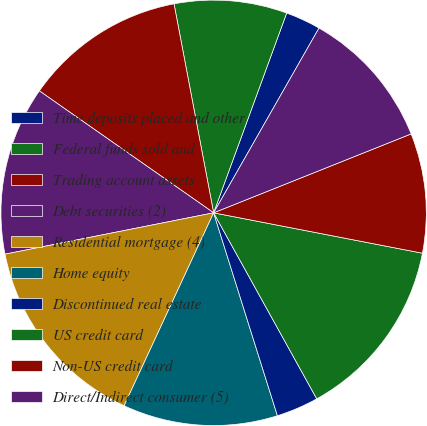Convert chart. <chart><loc_0><loc_0><loc_500><loc_500><pie_chart><fcel>Time deposits placed and other<fcel>Federal funds sold and<fcel>Trading account assets<fcel>Debt securities (2)<fcel>Residential mortgage (4)<fcel>Home equity<fcel>Discontinued real estate<fcel>US credit card<fcel>Non-US credit card<fcel>Direct/Indirect consumer (5)<nl><fcel>2.67%<fcel>8.56%<fcel>12.3%<fcel>12.83%<fcel>14.97%<fcel>11.76%<fcel>3.21%<fcel>13.9%<fcel>9.09%<fcel>10.7%<nl></chart> 